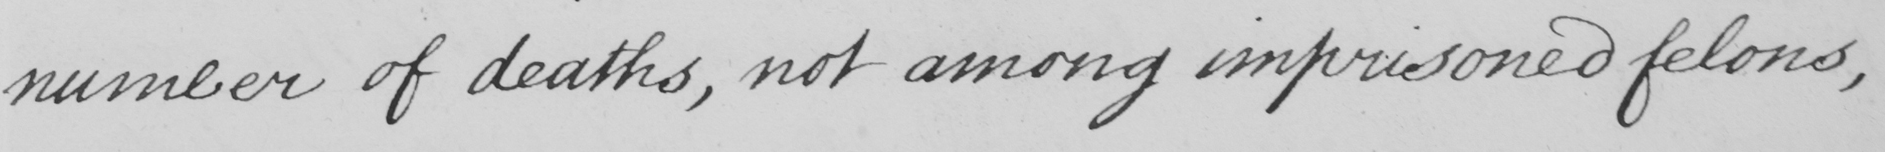What text is written in this handwritten line? number of deaths , not among imprisoned felons , 